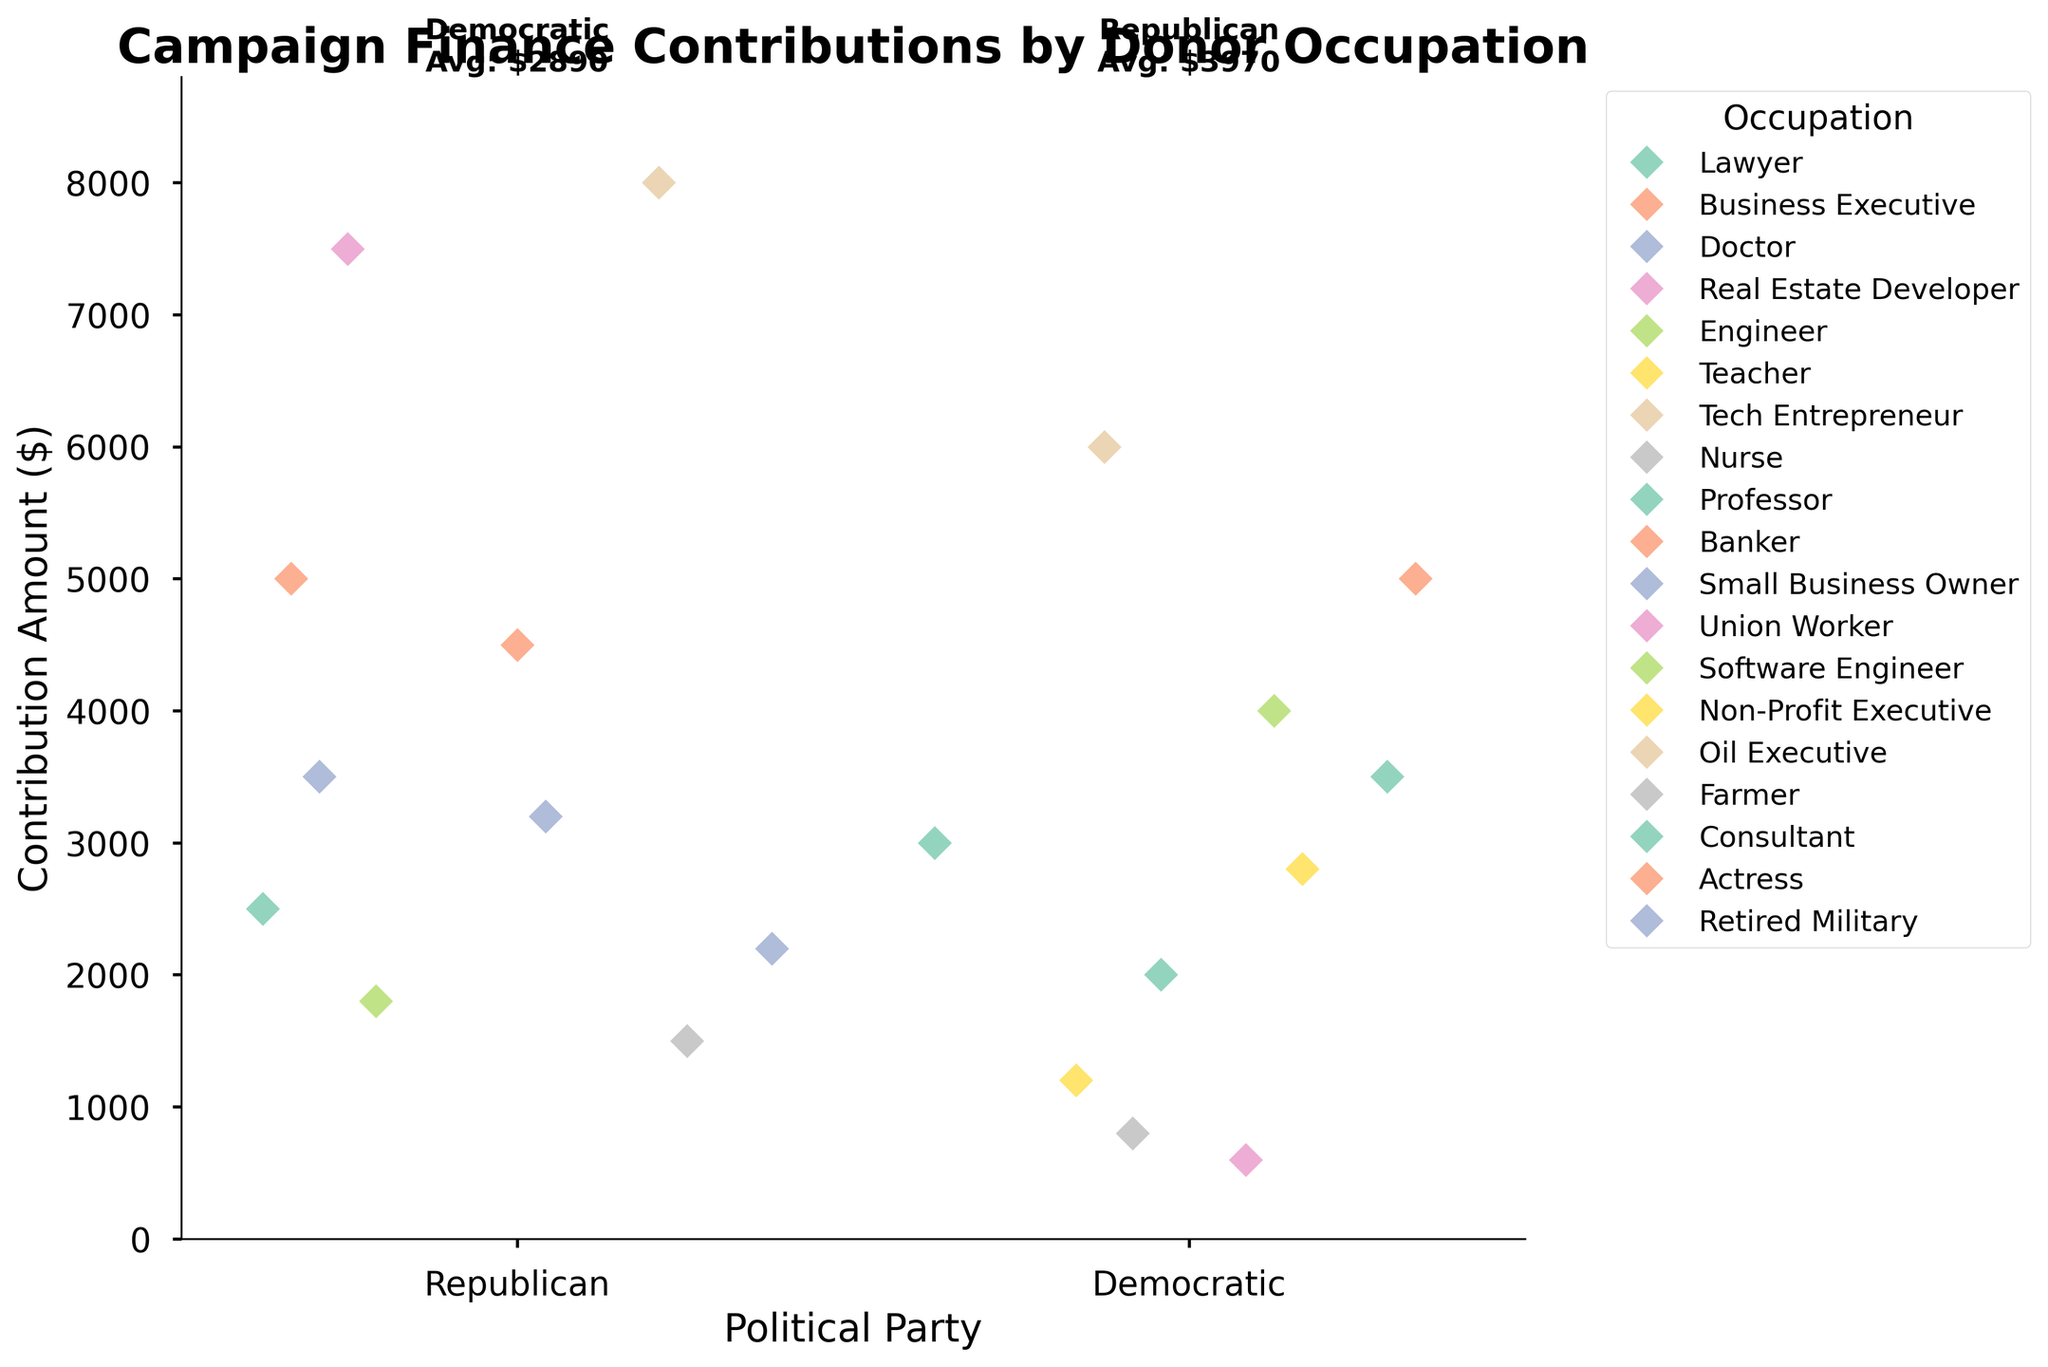What is the title of the figure? The title is located at the top of the figure. It is written in bold and larger font size compared to other text elements in the plot.
Answer: Campaign Finance Contributions by Donor Occupation What are the two political parties shown on the x-axis? The x-axis displays the political parties. The figure shows data points for two parties.
Answer: Democratic, Republican Which occupation has the highest contribution among the Republican party donors? Look at the data points for the Republican party. The highest y-value corresponds to the occupation labeled for that point.
Answer: Oil Executive What is the average contribution for the Democratic party donors? Locate the average annotation above the Democratic party. Follow the x-axis label and read the text above the y-axis.
Answer: $2900 Which party has a higher overall contribution from donors? Compare the height and density of the data points between the two parties. Alternatively, check the average contribution annotations above the x-axis labels.
Answer: Republican How many donors contributed more than $5000? Count the number of data points that are above the $5000 mark on the y-axis.
Answer: 5 Which occupation in the Democratic party has the smallest contribution amount? Look for the lowest data point on the y-axis for the Democratic party. Identify the occupation associated with that point.
Answer: Union Worker How many different occupations are there in the Republican party? Identify and count the different occupations in the legend associated with Republican data points.
Answer: 9 Compare the average contributions of the Democratic and Republican parties. Which one is higher and by how much? Compare the average annotations above each party and subtract the Democratic average from the Republican average.
Answer: Republican is higher by $810 What is the range of contributions for the Democratic party donors? Identify the lowest and highest data points for the Democratic party on the y-axis. Subtract the lowest value from the highest value.
Answer: $5400 